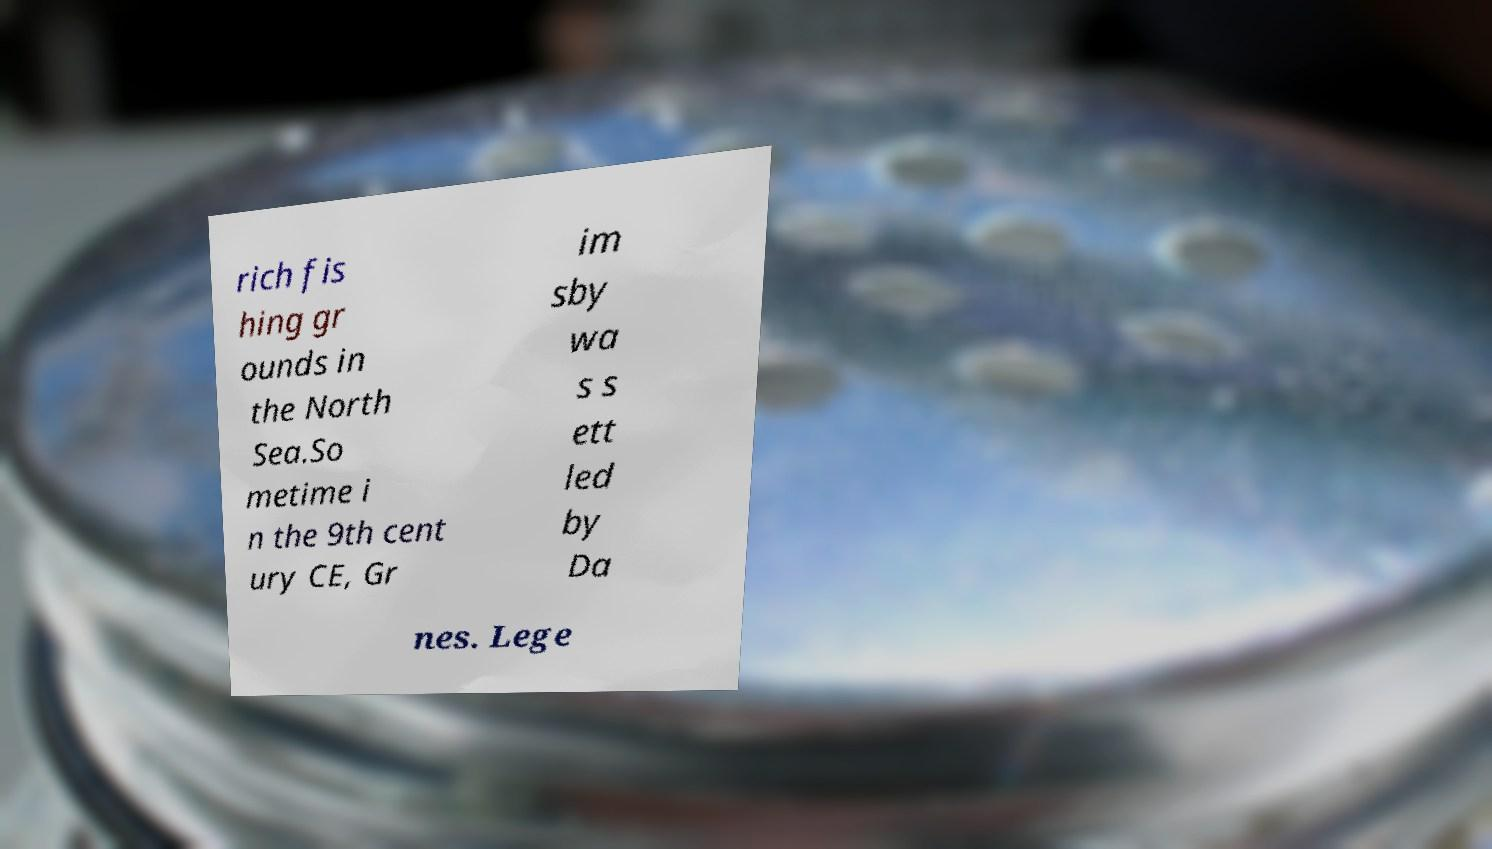Could you extract and type out the text from this image? rich fis hing gr ounds in the North Sea.So metime i n the 9th cent ury CE, Gr im sby wa s s ett led by Da nes. Lege 